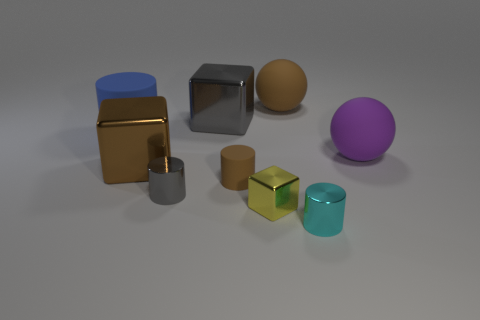Subtract all big cubes. How many cubes are left? 1 Add 1 tiny blue metallic balls. How many objects exist? 10 Subtract all purple balls. How many balls are left? 1 Subtract all cylinders. How many objects are left? 5 Subtract 2 blocks. How many blocks are left? 1 Subtract 0 purple cylinders. How many objects are left? 9 Subtract all red cubes. Subtract all gray spheres. How many cubes are left? 3 Subtract all gray cylinders. Subtract all gray shiny objects. How many objects are left? 6 Add 4 big rubber objects. How many big rubber objects are left? 7 Add 1 small brown matte cylinders. How many small brown matte cylinders exist? 2 